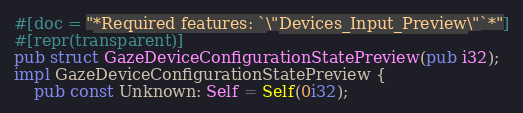Convert code to text. <code><loc_0><loc_0><loc_500><loc_500><_Rust_>#[doc = "*Required features: `\"Devices_Input_Preview\"`*"]
#[repr(transparent)]
pub struct GazeDeviceConfigurationStatePreview(pub i32);
impl GazeDeviceConfigurationStatePreview {
    pub const Unknown: Self = Self(0i32);</code> 